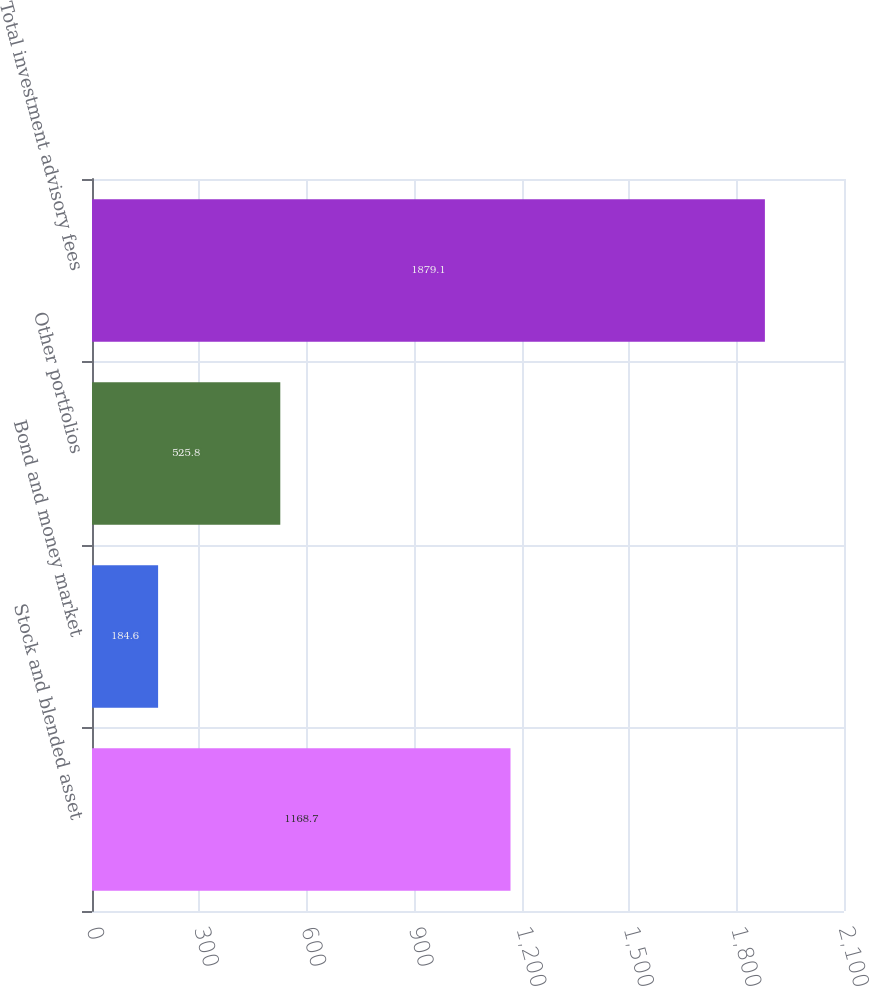Convert chart to OTSL. <chart><loc_0><loc_0><loc_500><loc_500><bar_chart><fcel>Stock and blended asset<fcel>Bond and money market<fcel>Other portfolios<fcel>Total investment advisory fees<nl><fcel>1168.7<fcel>184.6<fcel>525.8<fcel>1879.1<nl></chart> 